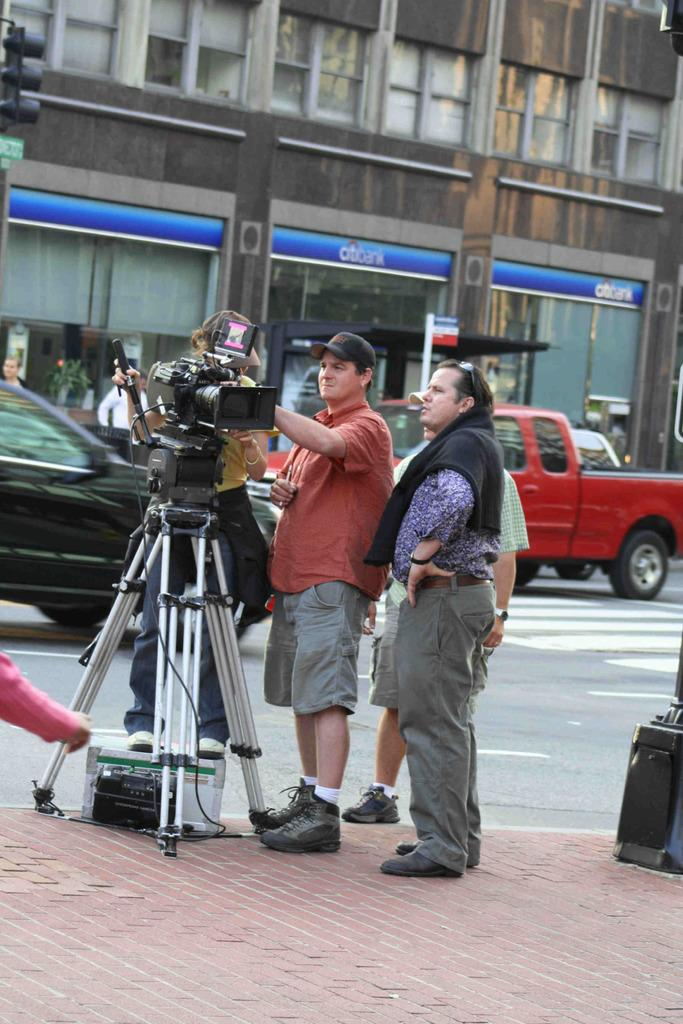What is the main object in the image? There is a camera on a stand in the image. Who is present near the camera? There are people standing beside the camera. What else can be seen in the image besides the camera and people? There are vehicles visible in the image. What is visible in the background of the image? There is a building in the background of the image. How many screws are visible on the camera in the image? There is no information about screws on the camera in the provided facts, so we cannot determine the number of screws visible. What type of zipper can be seen on the people standing beside the camera? There is no mention of zippers on the people in the image, so we cannot determine if any zippers are present. 